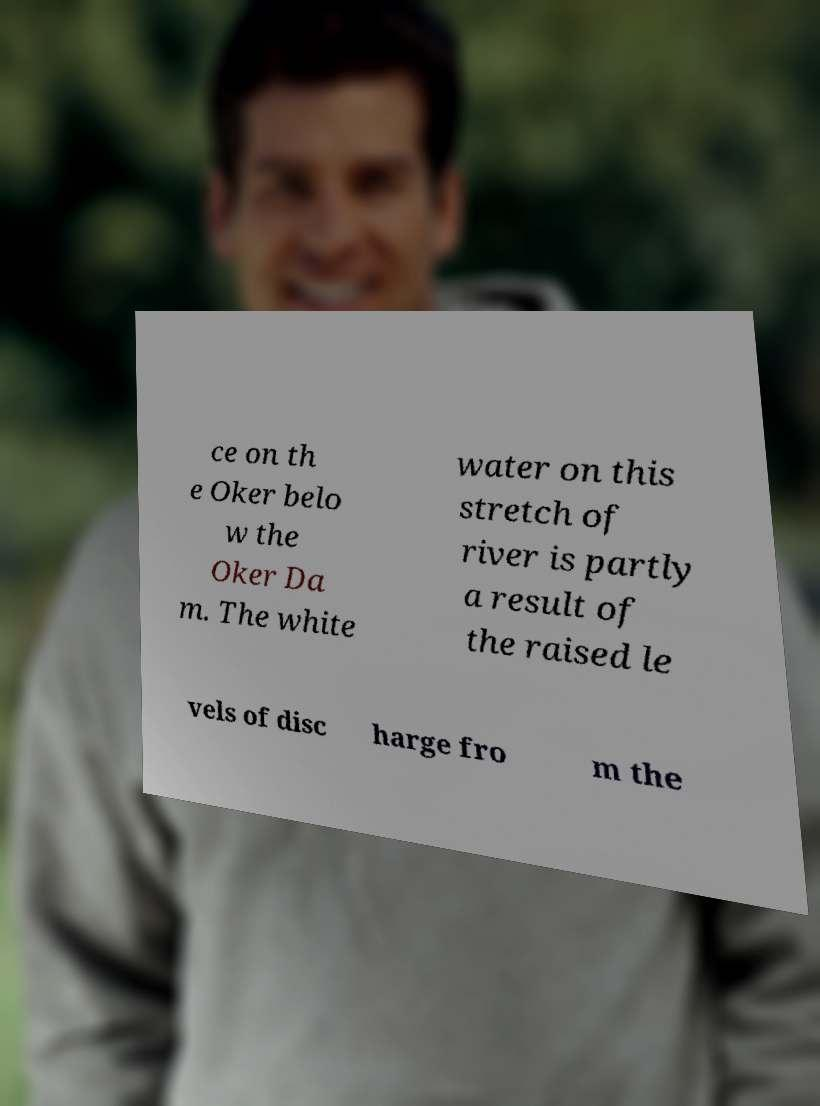Could you assist in decoding the text presented in this image and type it out clearly? ce on th e Oker belo w the Oker Da m. The white water on this stretch of river is partly a result of the raised le vels of disc harge fro m the 